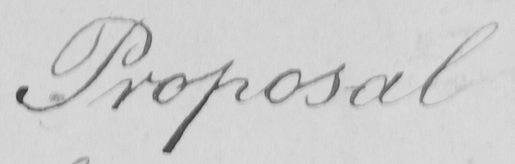Can you read and transcribe this handwriting? Proposal 